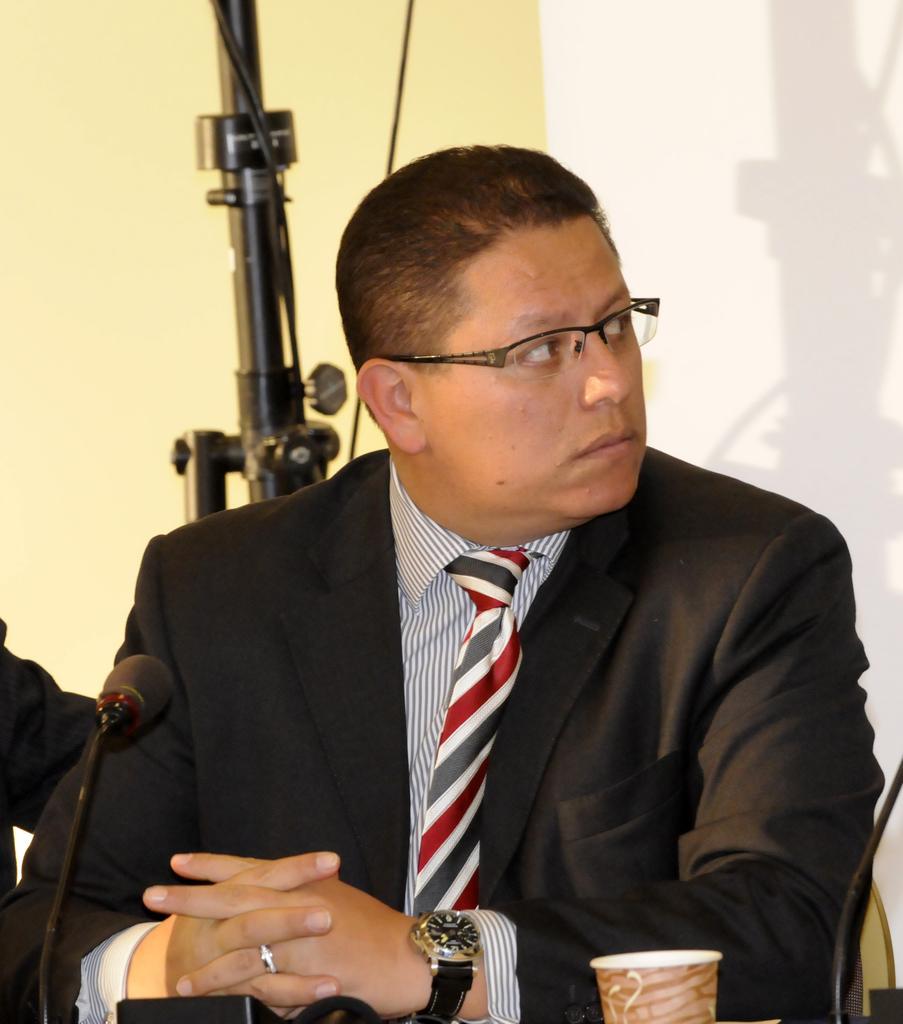Please provide a concise description of this image. In the picture we can see a man sitting near the desk on it, we can see a glass and a microphone and a man is in blazer, tie and shirt and behind him we can see a stand and behind it, we can see a wall which is light yellow in color and some part of the wall is white in color. 